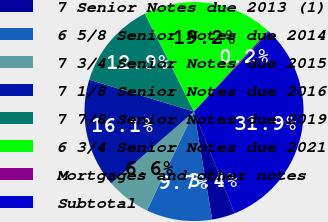<chart> <loc_0><loc_0><loc_500><loc_500><pie_chart><fcel>7 Senior Notes due 2013 (1)<fcel>6 5/8 Senior Notes due 2014<fcel>7 3/4 Senior Notes due 2015<fcel>7 1/8 Senior Notes due 2016<fcel>7 7/8 Senior Notes due 2019<fcel>6 3/4 Senior Notes due 2021<fcel>Mortgages and other notes<fcel>Subtotal<nl><fcel>3.39%<fcel>9.73%<fcel>6.56%<fcel>16.06%<fcel>12.9%<fcel>19.23%<fcel>0.22%<fcel>31.91%<nl></chart> 